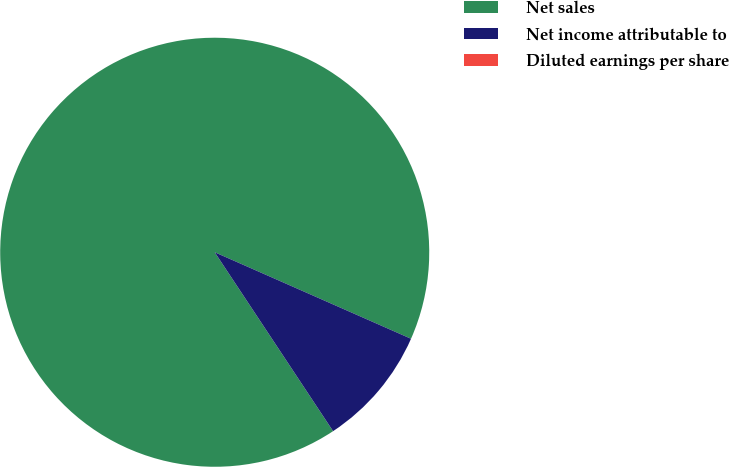Convert chart to OTSL. <chart><loc_0><loc_0><loc_500><loc_500><pie_chart><fcel>Net sales<fcel>Net income attributable to<fcel>Diluted earnings per share<nl><fcel>90.91%<fcel>9.09%<fcel>0.0%<nl></chart> 